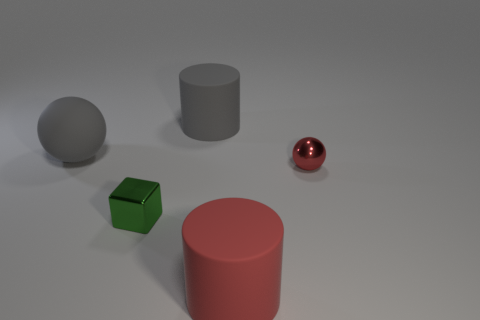Add 2 gray matte things. How many objects exist? 7 Subtract all blocks. How many objects are left? 4 Subtract all large purple metallic objects. Subtract all red balls. How many objects are left? 4 Add 3 large gray rubber cylinders. How many large gray rubber cylinders are left? 4 Add 5 tiny cyan metallic balls. How many tiny cyan metallic balls exist? 5 Subtract 0 brown cylinders. How many objects are left? 5 